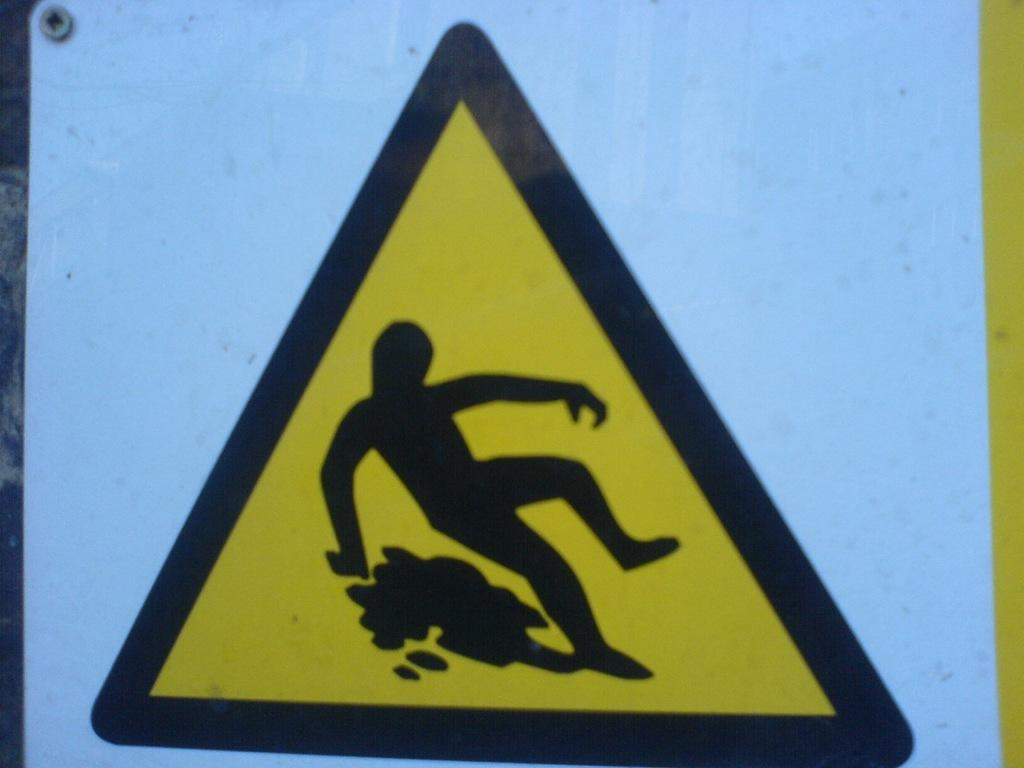What is the main object in the image? There is a board in the image. What is depicted on the board? There is a painting of a person on the board. What type of acoustics can be heard from the painting on the board? The painting on the board is not capable of producing sound, so there are no acoustics to be heard. 